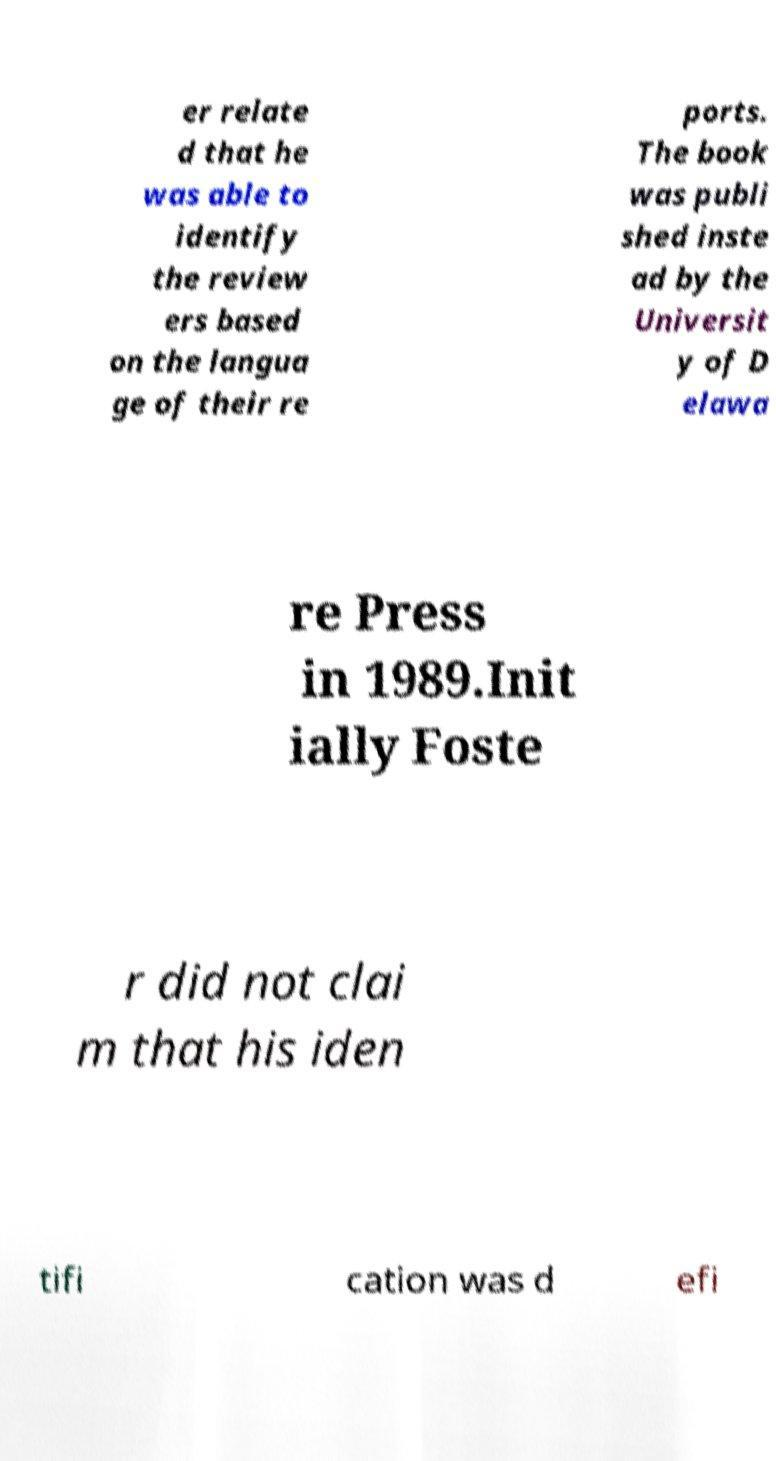Can you read and provide the text displayed in the image?This photo seems to have some interesting text. Can you extract and type it out for me? er relate d that he was able to identify the review ers based on the langua ge of their re ports. The book was publi shed inste ad by the Universit y of D elawa re Press in 1989.Init ially Foste r did not clai m that his iden tifi cation was d efi 